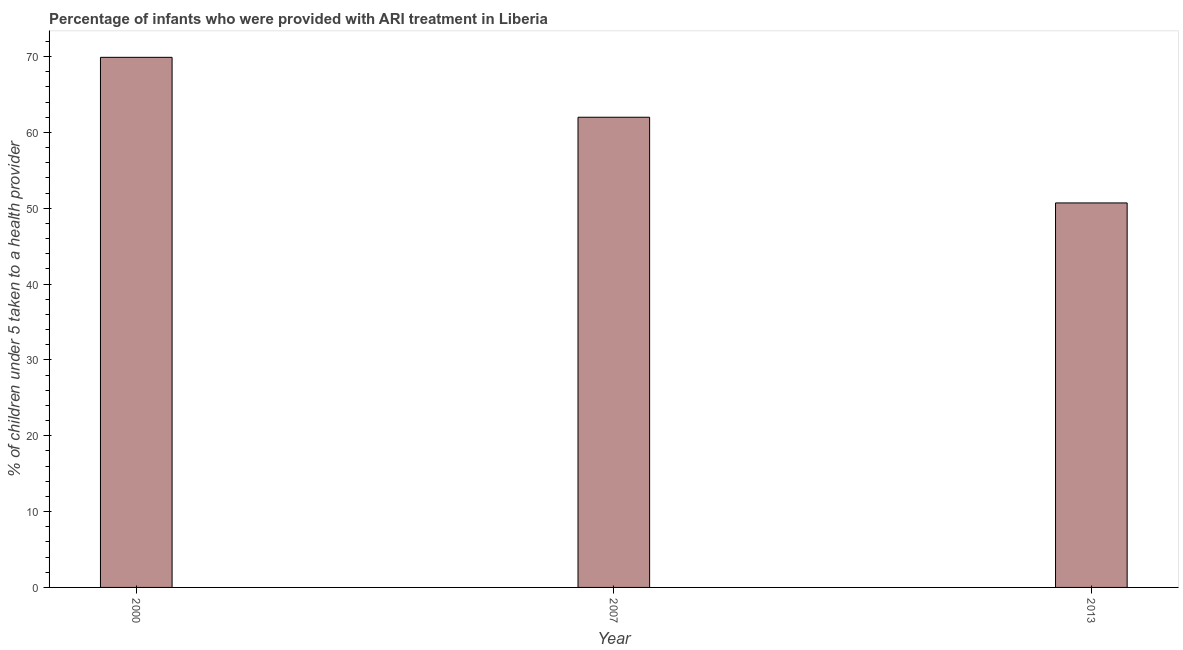Does the graph contain any zero values?
Provide a succinct answer. No. What is the title of the graph?
Make the answer very short. Percentage of infants who were provided with ARI treatment in Liberia. What is the label or title of the Y-axis?
Make the answer very short. % of children under 5 taken to a health provider. What is the percentage of children who were provided with ari treatment in 2013?
Provide a succinct answer. 50.7. Across all years, what is the maximum percentage of children who were provided with ari treatment?
Offer a very short reply. 69.9. Across all years, what is the minimum percentage of children who were provided with ari treatment?
Offer a very short reply. 50.7. In which year was the percentage of children who were provided with ari treatment maximum?
Your response must be concise. 2000. What is the sum of the percentage of children who were provided with ari treatment?
Your response must be concise. 182.6. What is the average percentage of children who were provided with ari treatment per year?
Ensure brevity in your answer.  60.87. What is the median percentage of children who were provided with ari treatment?
Your answer should be compact. 62. Do a majority of the years between 2000 and 2007 (inclusive) have percentage of children who were provided with ari treatment greater than 14 %?
Your response must be concise. Yes. What is the ratio of the percentage of children who were provided with ari treatment in 2000 to that in 2007?
Provide a short and direct response. 1.13. Is the difference between the percentage of children who were provided with ari treatment in 2000 and 2013 greater than the difference between any two years?
Your answer should be very brief. Yes. Is the sum of the percentage of children who were provided with ari treatment in 2007 and 2013 greater than the maximum percentage of children who were provided with ari treatment across all years?
Make the answer very short. Yes. What is the difference between the highest and the lowest percentage of children who were provided with ari treatment?
Offer a very short reply. 19.2. How many bars are there?
Offer a very short reply. 3. Are all the bars in the graph horizontal?
Offer a terse response. No. What is the % of children under 5 taken to a health provider in 2000?
Make the answer very short. 69.9. What is the % of children under 5 taken to a health provider in 2013?
Offer a terse response. 50.7. What is the difference between the % of children under 5 taken to a health provider in 2000 and 2013?
Your response must be concise. 19.2. What is the difference between the % of children under 5 taken to a health provider in 2007 and 2013?
Ensure brevity in your answer.  11.3. What is the ratio of the % of children under 5 taken to a health provider in 2000 to that in 2007?
Ensure brevity in your answer.  1.13. What is the ratio of the % of children under 5 taken to a health provider in 2000 to that in 2013?
Your answer should be very brief. 1.38. What is the ratio of the % of children under 5 taken to a health provider in 2007 to that in 2013?
Give a very brief answer. 1.22. 